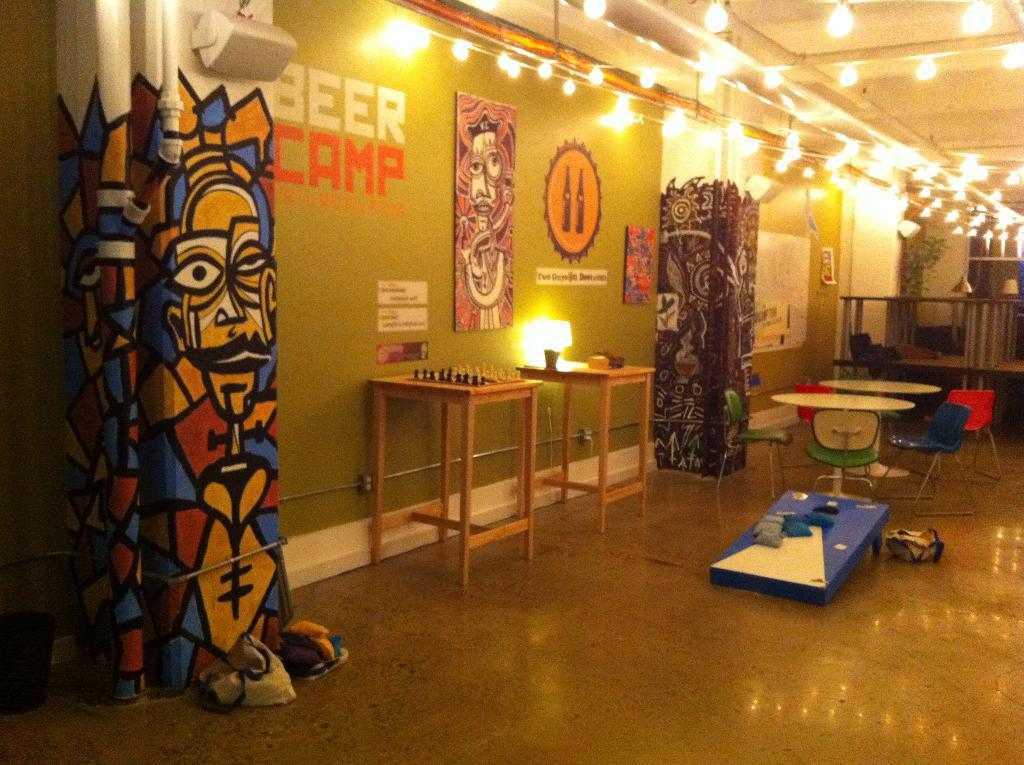Provide a one-sentence caption for the provided image. a room with BEER CAMP written on the wall with chess, table and chairs and a bean bag toss game. 